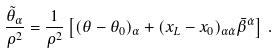Convert formula to latex. <formula><loc_0><loc_0><loc_500><loc_500>\frac { \tilde { \theta } _ { \alpha } } { \rho ^ { 2 } } = \frac { 1 } { \rho ^ { 2 } } \left [ ( \theta - \theta _ { 0 } ) _ { \alpha } + ( x _ { L } - x _ { 0 } ) _ { \alpha \dot { \alpha } } \bar { \beta } ^ { \dot { \alpha } } \right ] \, .</formula> 